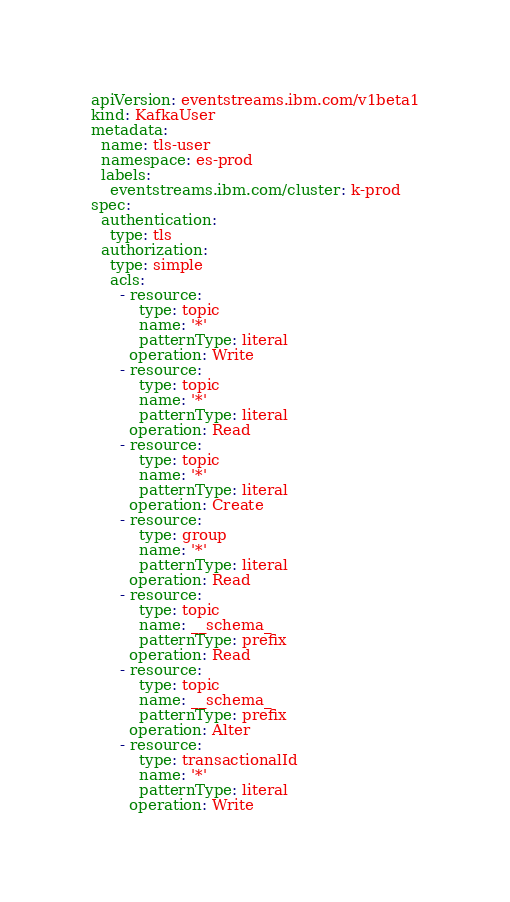<code> <loc_0><loc_0><loc_500><loc_500><_YAML_>apiVersion: eventstreams.ibm.com/v1beta1
kind: KafkaUser
metadata:
  name: tls-user
  namespace: es-prod
  labels:
    eventstreams.ibm.com/cluster: k-prod
spec:
  authentication:
    type: tls
  authorization:
    type: simple
    acls:
      - resource:
          type: topic
          name: '*'
          patternType: literal
        operation: Write
      - resource:
          type: topic
          name: '*'
          patternType: literal
        operation: Read
      - resource:
          type: topic
          name: '*'
          patternType: literal
        operation: Create
      - resource:
          type: group
          name: '*'
          patternType: literal
        operation: Read
      - resource:
          type: topic
          name: __schema_
          patternType: prefix
        operation: Read
      - resource:
          type: topic
          name: __schema_
          patternType: prefix
        operation: Alter
      - resource:
          type: transactionalId
          name: '*'
          patternType: literal
        operation: Write</code> 